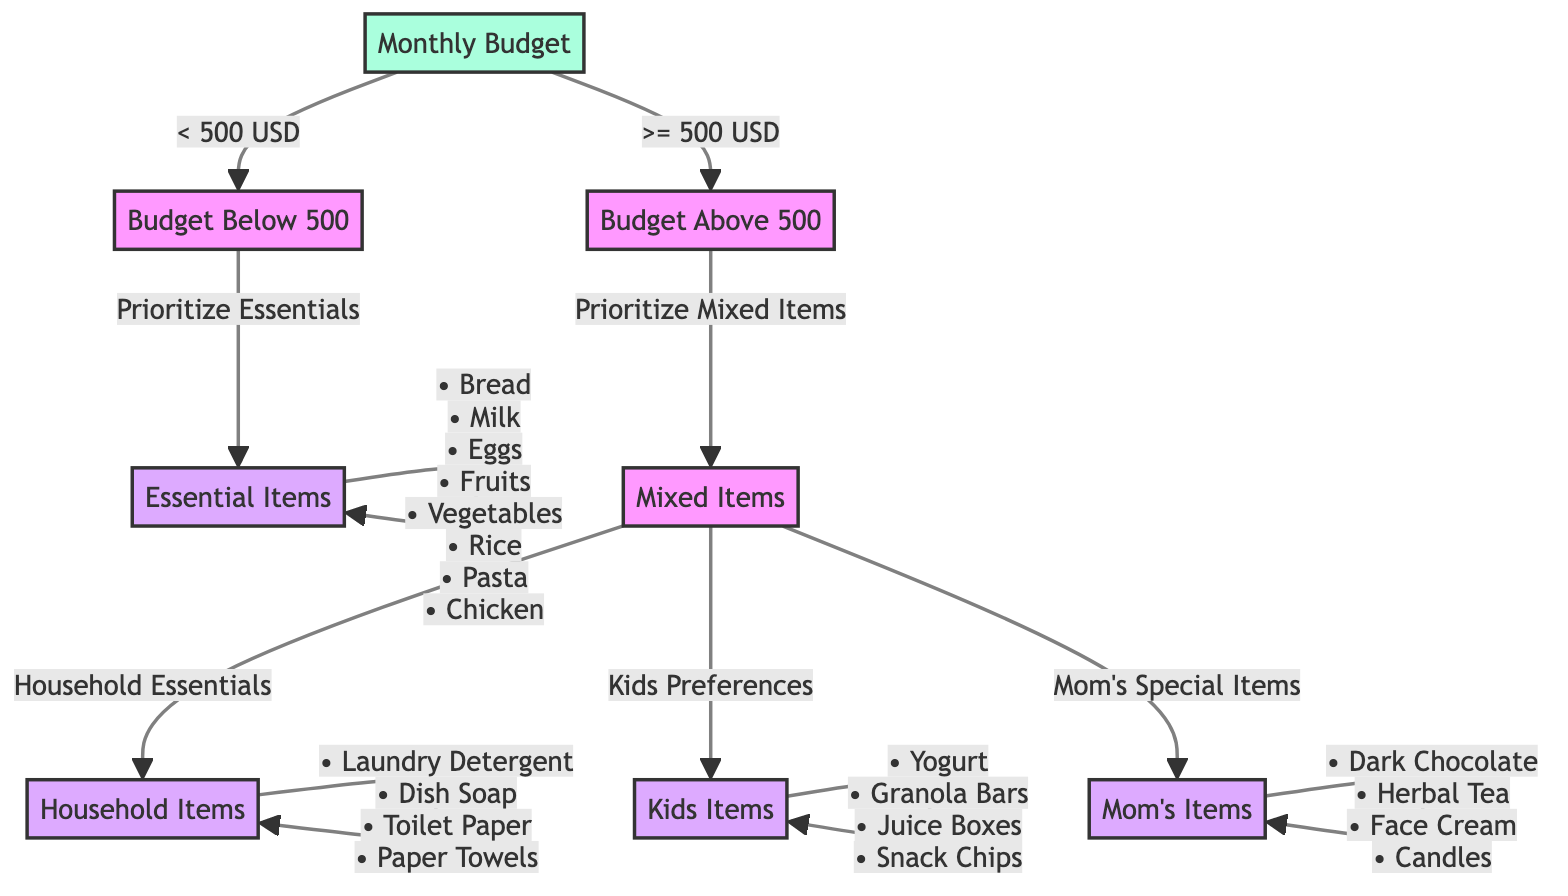What's the first decision in the diagram? The first decision is based on the Monthly Budget, which splits into two edges: Budget Below 500 or Budget Above 500.
Answer: Monthly Budget What items are included in the Essentials List? The Essentials List includes all items listed in the node labeled EssentialsList: Bread, Milk, Eggs, Fruits, Vegetables, Rice, Pasta, and Chicken.
Answer: Bread, Milk, Eggs, Fruits, Vegetables, Rice, Pasta, Chicken How many edges lead from the Budget Above 500 node? The Budget Above 500 node has three edges leading to other nodes: Household Essentials, Kids Preferences, and Mom's Special Items.
Answer: 3 What type of items does the node "KidsPreferencesList" include? The KidsPreferencesList includes specific items that cater to children's tastes, namely: Yogurt, Granola Bars, Juice Boxes, and Snack Chips.
Answer: Yogurt, Granola Bars, Juice Boxes, Snack Chips If the Monthly Budget is less than 500 USD, what will be prioritized? If the Monthly Budget is less than 500 USD, the decision tree indicates that Essentials will be prioritized to stay within budget.
Answer: Prioritize Essentials If the Monthly Budget is greater than or equal to 500 USD, what is the initial action taken? When the Monthly Budget is greater than or equal to 500 USD, the first action is to prioritize Mixed Items.
Answer: Prioritize Mixed Items What is the list of Household Essentials? The Household Essentials List contains items necessary for maintaining the household: Laundry Detergent, Dish Soap, Toilet Paper, and Paper Towels.
Answer: Laundry Detergent, Dish Soap, Toilet Paper, Paper Towels Where do the edges lead from the Mixed Items node? From the Mixed Items node, edges lead to three lists: Household Essentials, Kids Preferences, and Mom's Special Items.
Answer: Household Essentials, Kids Preferences, Mom's Special Items What happens when the Monthly Budget is less than 500 USD? When the Monthly Budget is less than 500 USD, it leads to the prioritization of essential items for necessary purchases.
Answer: Prioritize Essentials 